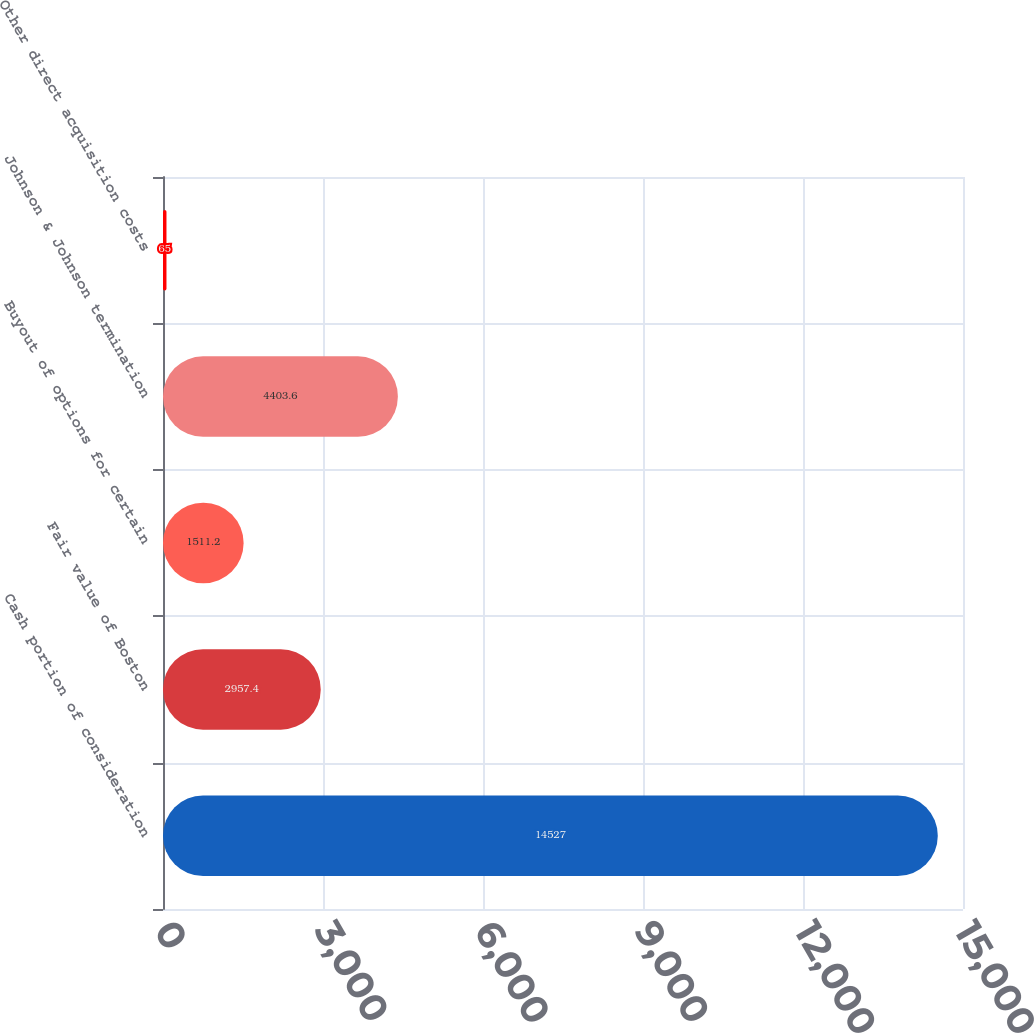Convert chart to OTSL. <chart><loc_0><loc_0><loc_500><loc_500><bar_chart><fcel>Cash portion of consideration<fcel>Fair value of Boston<fcel>Buyout of options for certain<fcel>Johnson & Johnson termination<fcel>Other direct acquisition costs<nl><fcel>14527<fcel>2957.4<fcel>1511.2<fcel>4403.6<fcel>65<nl></chart> 